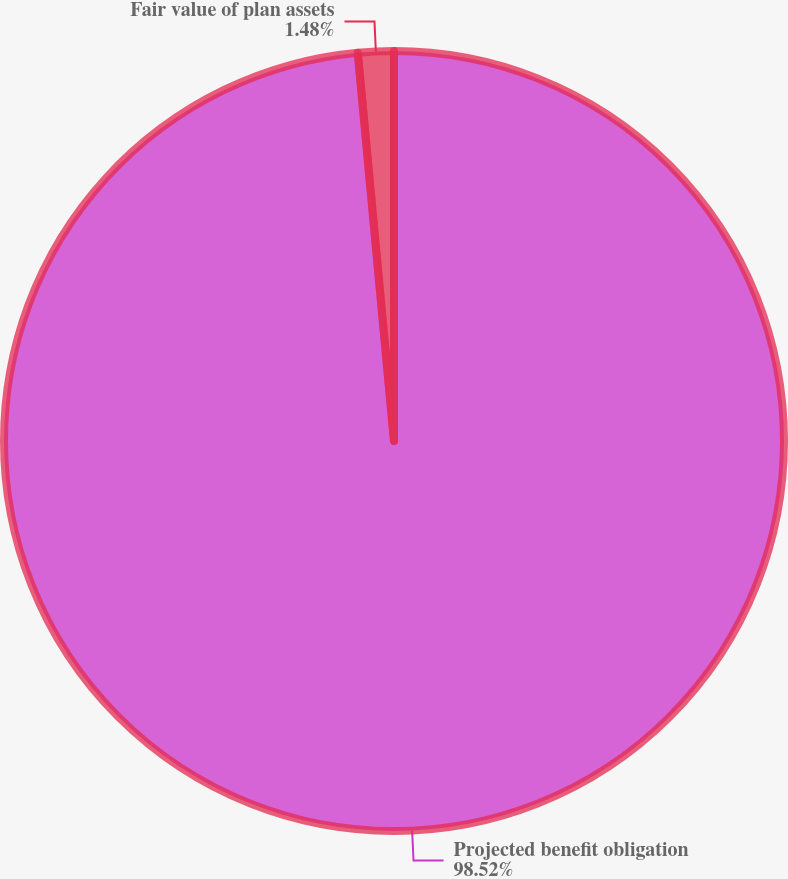Convert chart to OTSL. <chart><loc_0><loc_0><loc_500><loc_500><pie_chart><fcel>Projected benefit obligation<fcel>Fair value of plan assets<nl><fcel>98.52%<fcel>1.48%<nl></chart> 